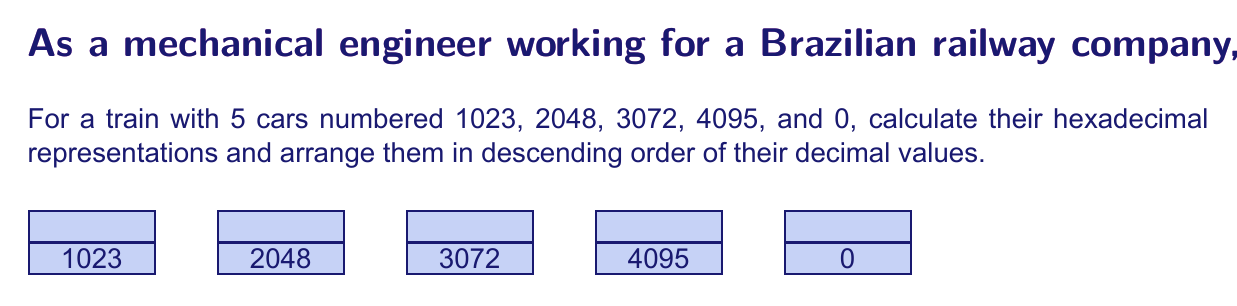Show me your answer to this math problem. To solve this problem, we need to convert each decimal number to its hexadecimal equivalent. Let's go through this step-by-step:

1) For decimal to hexadecimal conversion, we divide the number by 16 repeatedly and keep track of the remainders. The remainders in reverse order form the hexadecimal number.

2) 1023 in hexadecimal:
   $1023 \div 16 = 63$ remainder $15$ (F)
   $63 \div 16 = 3$ remainder $15$ (F)
   $3 \div 16 = 0$ remainder $3$
   So, $1023_{10} = 3FF_{16}$

3) 2048 in hexadecimal:
   $2048 \div 16 = 128$ remainder $0$
   $128 \div 16 = 8$ remainder $0$
   $8 \div 16 = 0$ remainder $8$
   So, $2048_{10} = 800_{16}$

4) 3072 in hexadecimal:
   $3072 \div 16 = 192$ remainder $0$
   $192 \div 16 = 12$ remainder $0$
   $12 \div 16 = 0$ remainder $12$ (C)
   So, $3072_{10} = C00_{16}$

5) 4095 in hexadecimal:
   $4095 \div 16 = 255$ remainder $15$ (F)
   $255 \div 16 = 15$ remainder $15$ (F)
   $15 \div 16 = 0$ remainder $15$ (F)
   So, $4095_{10} = FFF_{16}$

6) 0 in hexadecimal is simply $0_{16}$

7) Arranging in descending order of decimal values:
   4095, 3072, 2048, 1023, 0

Therefore, the final arrangement in hexadecimal is:
FFF, C00, 800, 3FF, 0
Answer: FFF, C00, 800, 3FF, 0 